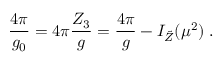Convert formula to latex. <formula><loc_0><loc_0><loc_500><loc_500>\frac { 4 \pi } { g _ { 0 } } = 4 \pi \frac { Z _ { 3 } } { g } = \frac { 4 \pi } { g } - I _ { \tilde { Z } } ( \mu ^ { 2 } ) \, .</formula> 